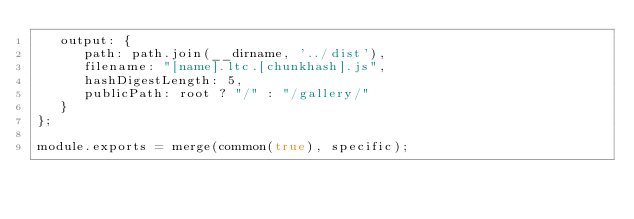Convert code to text. <code><loc_0><loc_0><loc_500><loc_500><_JavaScript_>   output: {
      path: path.join(__dirname, '../dist'),
      filename: "[name].ltc.[chunkhash].js",
      hashDigestLength: 5,
      publicPath: root ? "/" : "/gallery/"
   }
};

module.exports = merge(common(true), specific);
</code> 